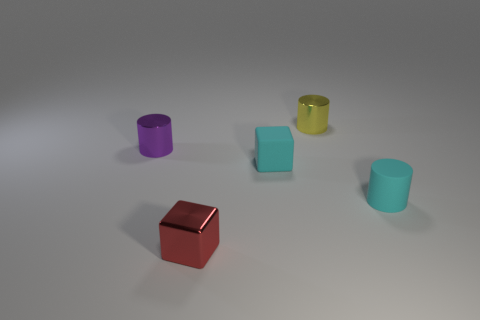Is the number of cyan cylinders that are in front of the yellow thing the same as the number of tiny cyan cylinders?
Provide a short and direct response. Yes. What number of other objects are there of the same color as the matte cylinder?
Your answer should be very brief. 1. Is the number of tiny rubber blocks that are behind the matte cube less than the number of tiny yellow rubber spheres?
Provide a succinct answer. No. Is there a block of the same size as the yellow metal thing?
Offer a very short reply. Yes. Is the color of the tiny rubber block the same as the small metal thing that is on the right side of the red thing?
Make the answer very short. No. There is a tiny cyan rubber thing that is behind the small rubber cylinder; how many purple things are on the left side of it?
Offer a very short reply. 1. The small block that is on the right side of the object in front of the small rubber cylinder is what color?
Ensure brevity in your answer.  Cyan. What is the object that is right of the small red metal block and left of the small yellow cylinder made of?
Make the answer very short. Rubber. Are there any tiny cyan rubber things of the same shape as the purple shiny object?
Your answer should be compact. Yes. There is a small cyan matte object to the right of the tiny yellow metal cylinder; is it the same shape as the tiny purple object?
Keep it short and to the point. Yes. 